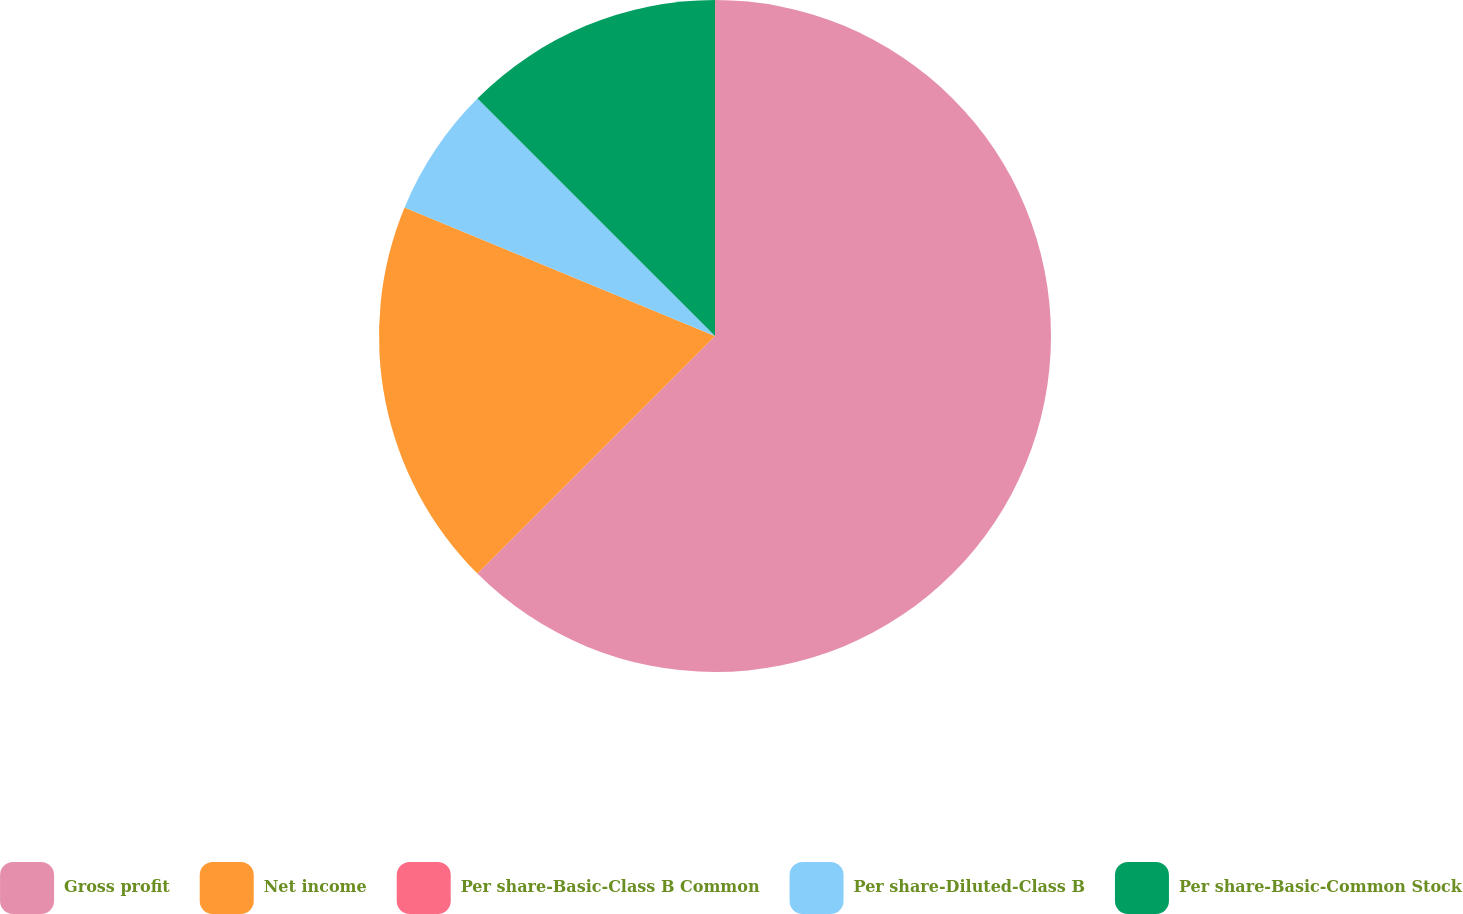Convert chart. <chart><loc_0><loc_0><loc_500><loc_500><pie_chart><fcel>Gross profit<fcel>Net income<fcel>Per share-Basic-Class B Common<fcel>Per share-Diluted-Class B<fcel>Per share-Basic-Common Stock<nl><fcel>62.5%<fcel>18.75%<fcel>0.0%<fcel>6.25%<fcel>12.5%<nl></chart> 